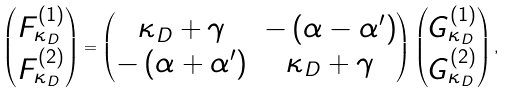Convert formula to latex. <formula><loc_0><loc_0><loc_500><loc_500>\begin{pmatrix} F ^ { ( 1 ) } _ { \kappa _ { D } } \\ F ^ { ( 2 ) } _ { \kappa _ { D } } \end{pmatrix} = \begin{pmatrix} \kappa _ { D } + \gamma & - \left ( \alpha - \alpha { ^ { \prime } } \right ) \\ - \left ( \alpha + \alpha { ^ { \prime } } \right ) & \kappa _ { D } + \gamma \end{pmatrix} \begin{pmatrix} G ^ { ( 1 ) } _ { \kappa _ { D } } \\ G ^ { ( 2 ) } _ { \kappa _ { D } } \end{pmatrix} ,</formula> 